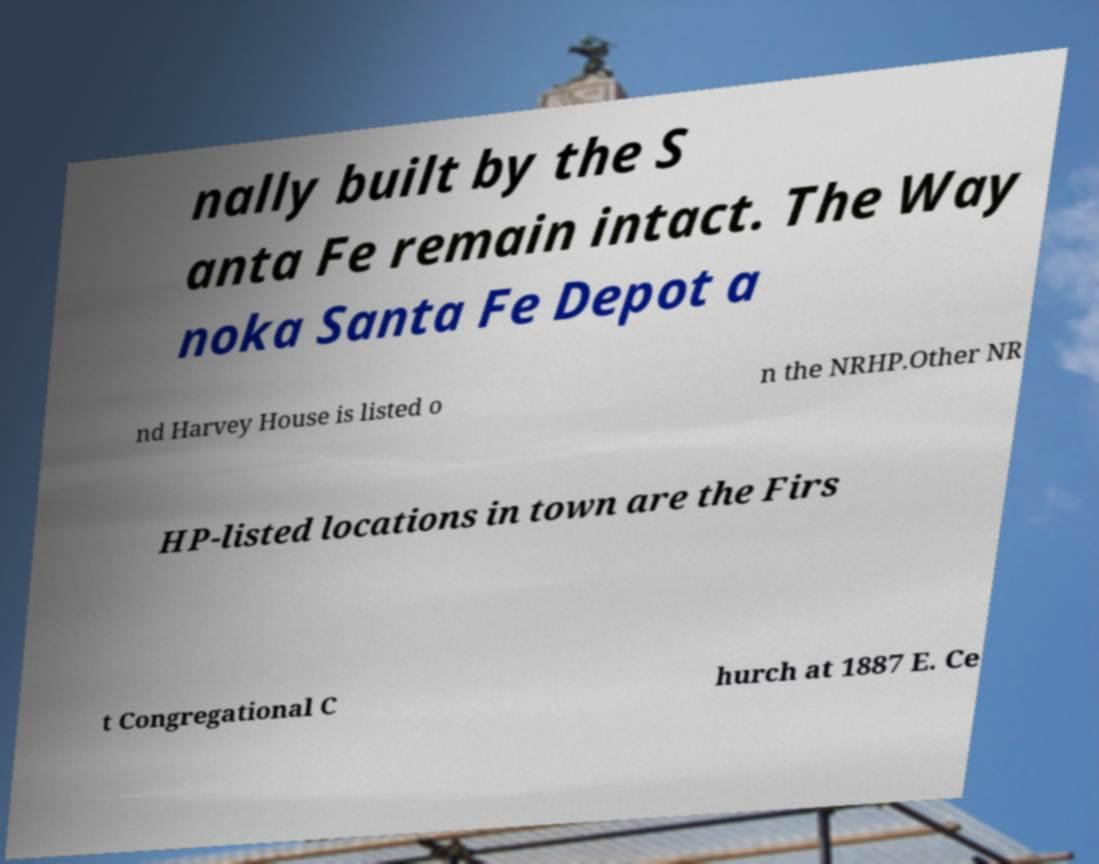Can you accurately transcribe the text from the provided image for me? nally built by the S anta Fe remain intact. The Way noka Santa Fe Depot a nd Harvey House is listed o n the NRHP.Other NR HP-listed locations in town are the Firs t Congregational C hurch at 1887 E. Ce 